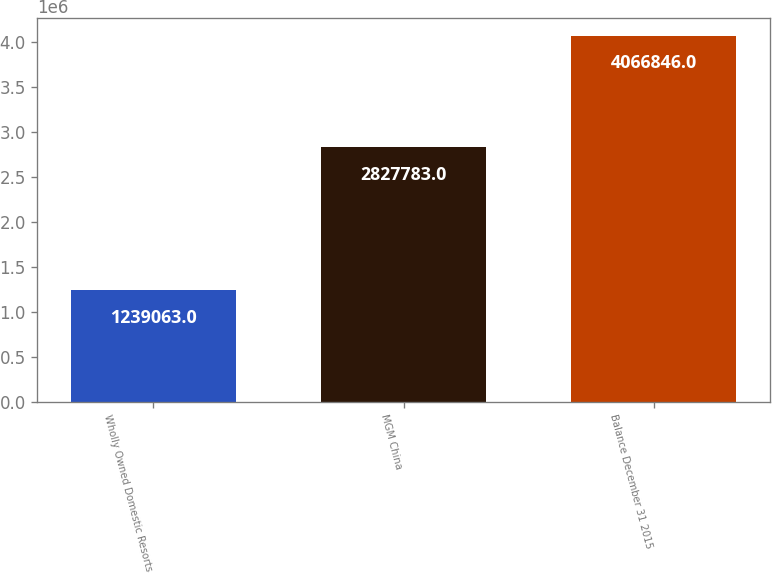Convert chart. <chart><loc_0><loc_0><loc_500><loc_500><bar_chart><fcel>Wholly Owned Domestic Resorts<fcel>MGM China<fcel>Balance December 31 2015<nl><fcel>1.23906e+06<fcel>2.82778e+06<fcel>4.06685e+06<nl></chart> 